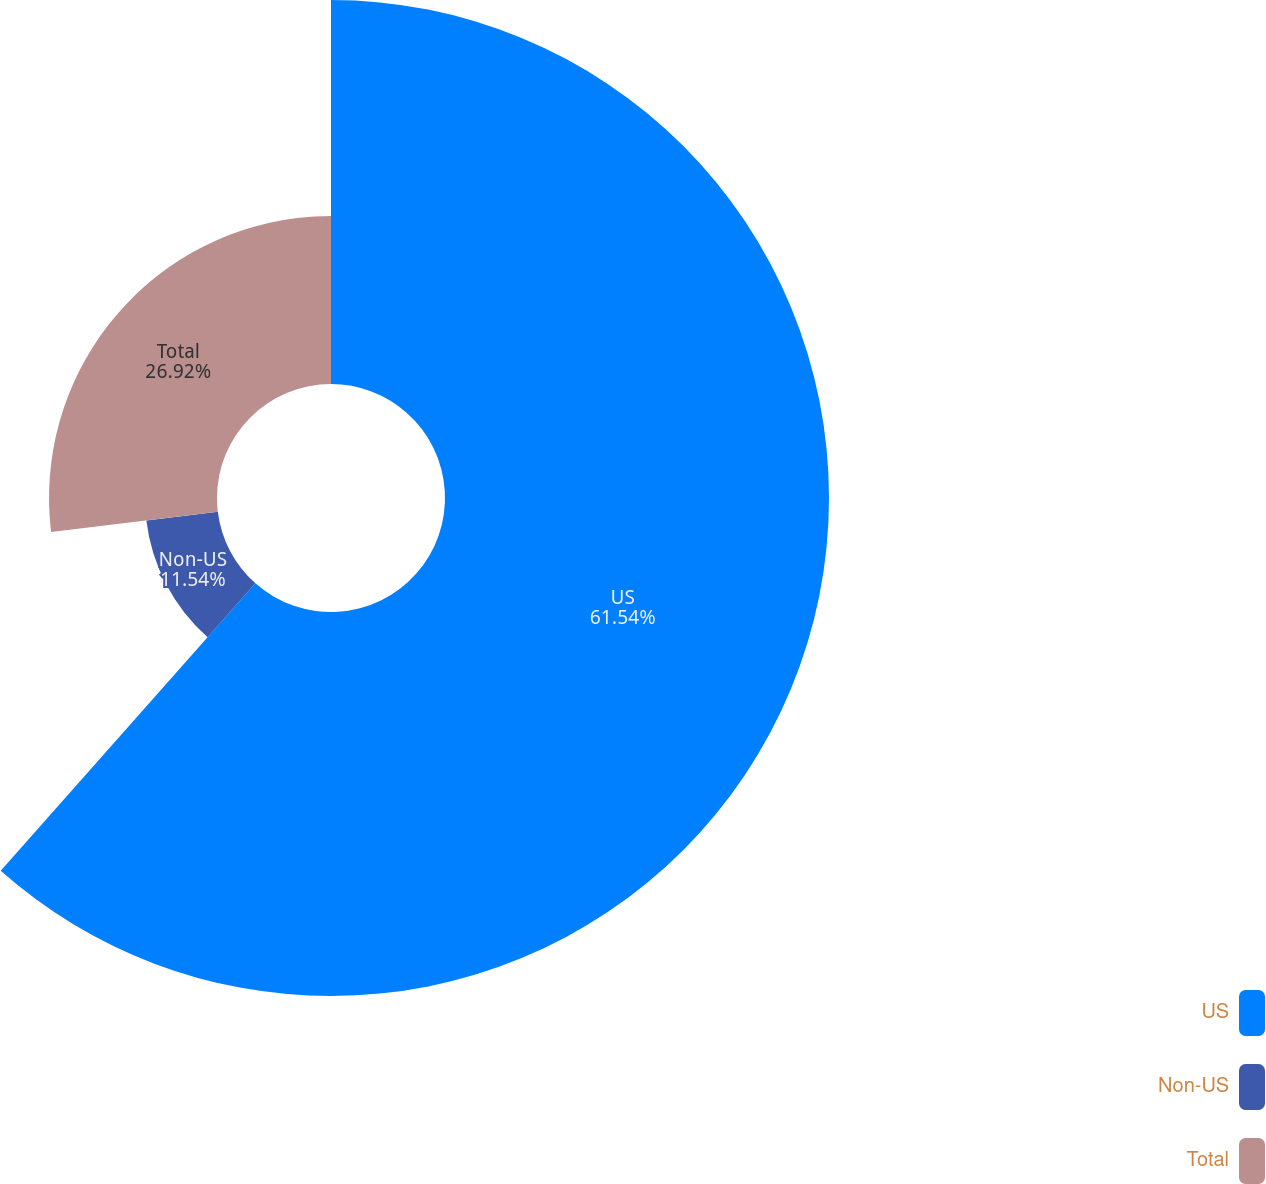Convert chart. <chart><loc_0><loc_0><loc_500><loc_500><pie_chart><fcel>US<fcel>Non-US<fcel>Total<nl><fcel>61.54%<fcel>11.54%<fcel>26.92%<nl></chart> 